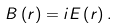Convert formula to latex. <formula><loc_0><loc_0><loc_500><loc_500>B \left ( r \right ) = i E \left ( r \right ) .</formula> 